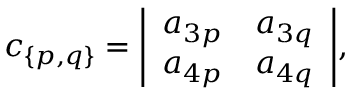Convert formula to latex. <formula><loc_0><loc_0><loc_500><loc_500>c _ { \{ p , q \} } = { \left | \begin{array} { l l } { a _ { 3 p } } & { a _ { 3 q } } \\ { a _ { 4 p } } & { a _ { 4 q } } \end{array} \right | } ,</formula> 